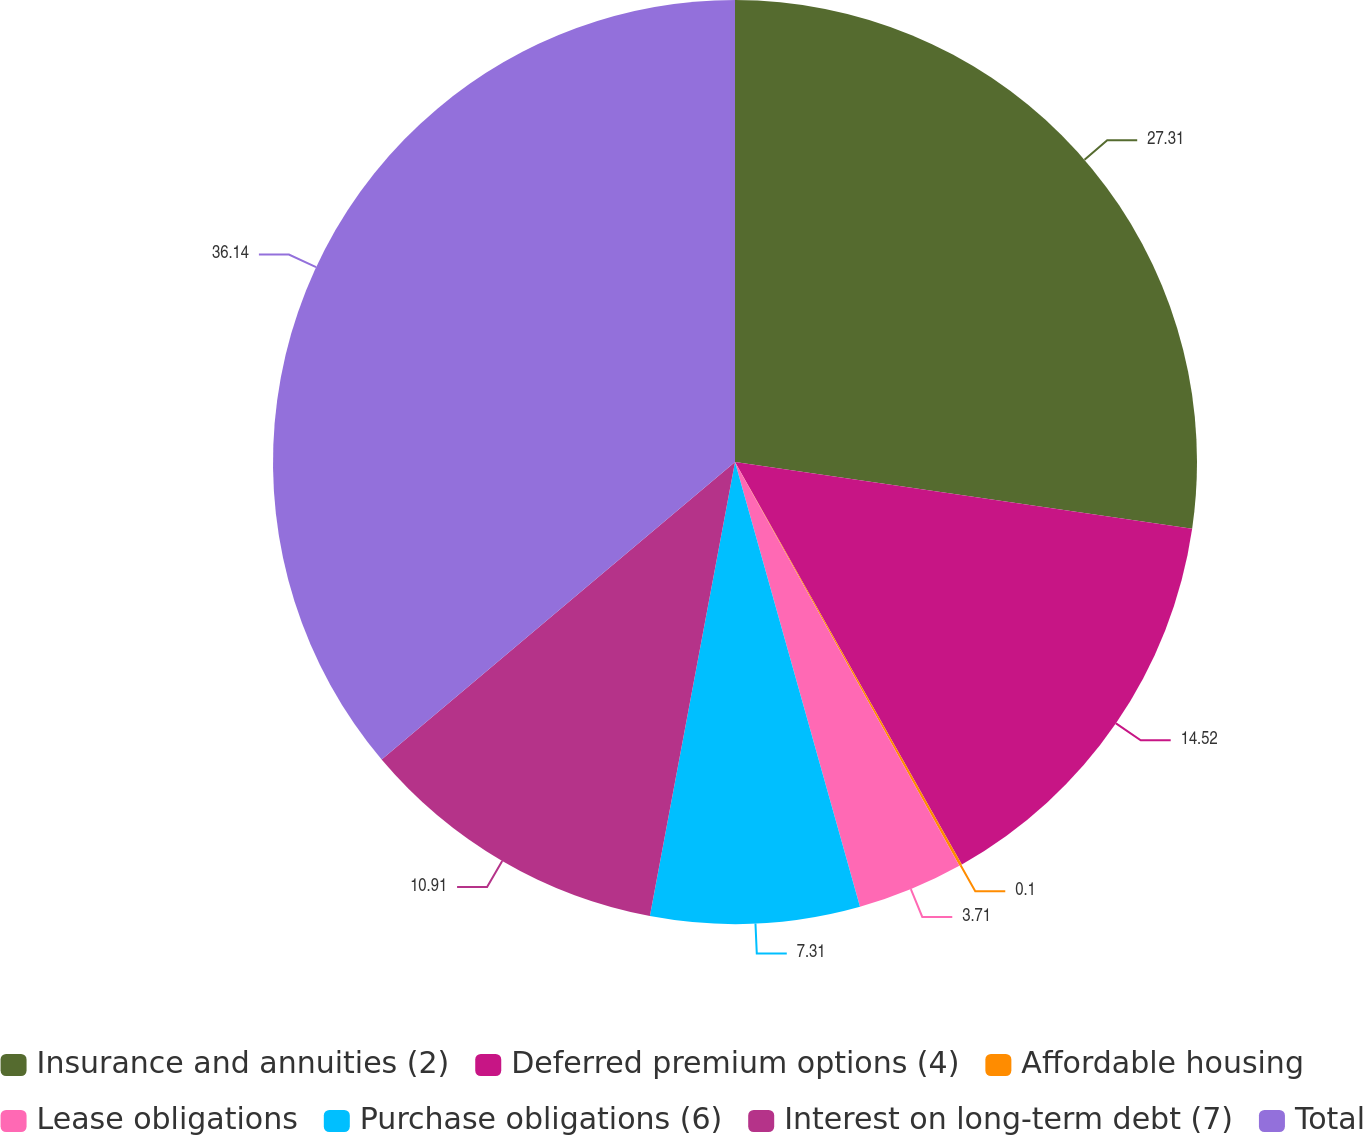Convert chart. <chart><loc_0><loc_0><loc_500><loc_500><pie_chart><fcel>Insurance and annuities (2)<fcel>Deferred premium options (4)<fcel>Affordable housing<fcel>Lease obligations<fcel>Purchase obligations (6)<fcel>Interest on long-term debt (7)<fcel>Total<nl><fcel>27.31%<fcel>14.52%<fcel>0.1%<fcel>3.71%<fcel>7.31%<fcel>10.91%<fcel>36.14%<nl></chart> 